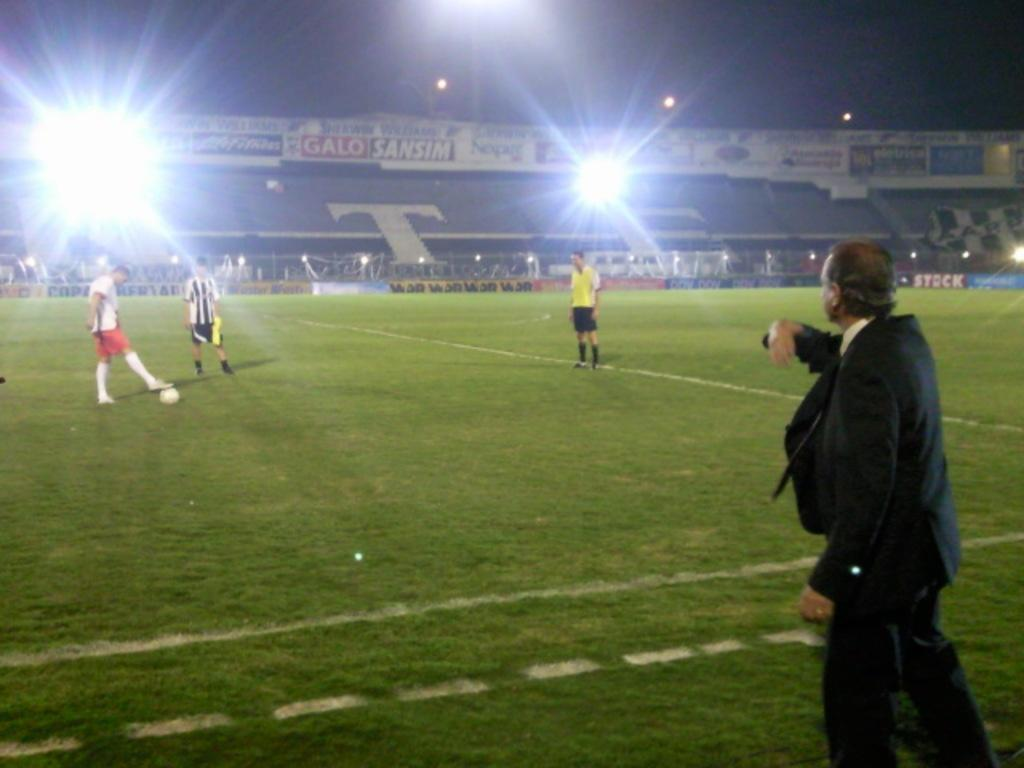<image>
Create a compact narrative representing the image presented. night time on soccer field with man in suit in front and stands have a large T on it in background 